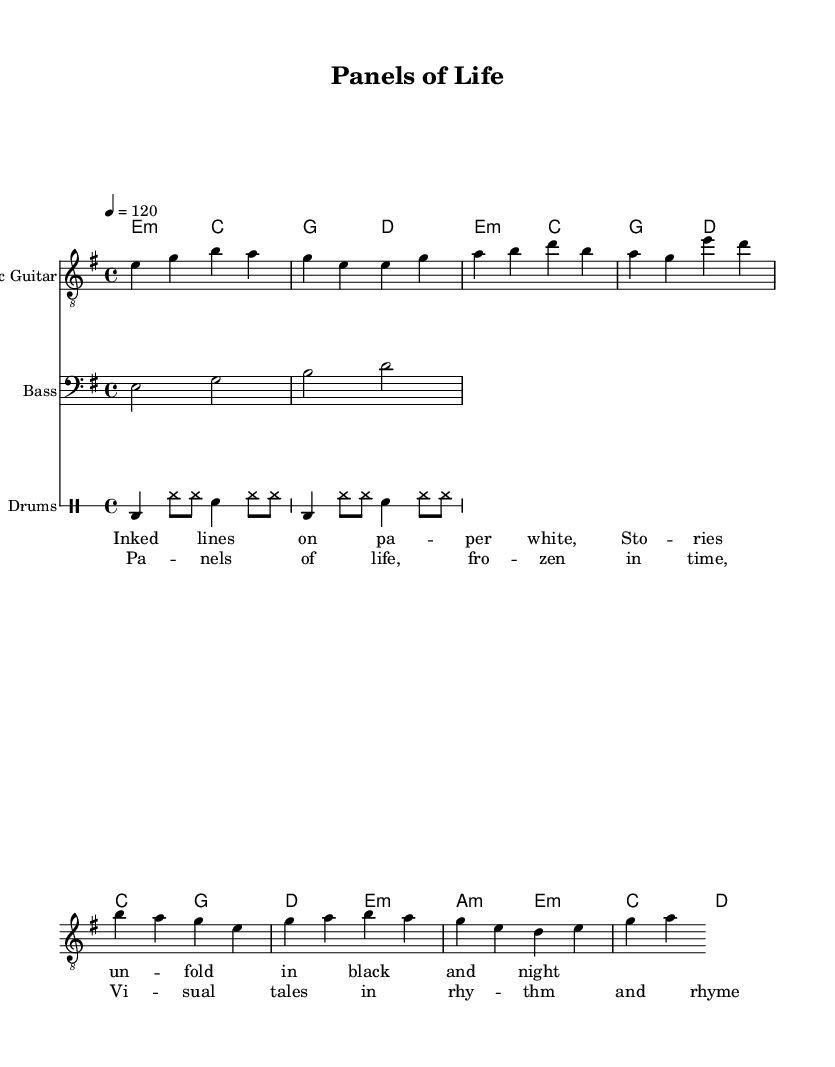What is the key signature of this music? The key signature determined by the global settings in the sheet music specifies E minor, which has one sharp (F#).
Answer: E minor What is the time signature of this music? The time signature is found in the global settings and indicates how many beats are in each measure. Here, it is 4/4, meaning there are four beats per measure.
Answer: 4/4 What is the tempo of this piece? The tempo is indicated in the global settings, showing that it is set to 120 beats per minute, which means the quarter note gets one beat at that speed.
Answer: 120 How many measures are in the verse section? Counting the measures in the electric guitar section, the verse has a total of 4 measures, denoted by the vertical lines separating the different sections.
Answer: 4 What chords are used in the chorus? Reviewing the chord names section, the chords listed for the chorus are C, G, D, and E minor, showing the harmonic structure of this specific part of the song.
Answer: C, G, D, E minor Which instrument plays the introductory part? Looking at the score layout, the electric guitar plays the introductory part of the piece as shown in the first part of the electric guitar section.
Answer: Electric Guitar How is the rhythm structured in the drum pattern? The drum pattern shows a repetitive rhythmic structure that includes bass drums, hi-hat, and snare. It uses alternating notes which contribute to a driving rock rhythm.
Answer: Alternating bass, hi-hat, snare 